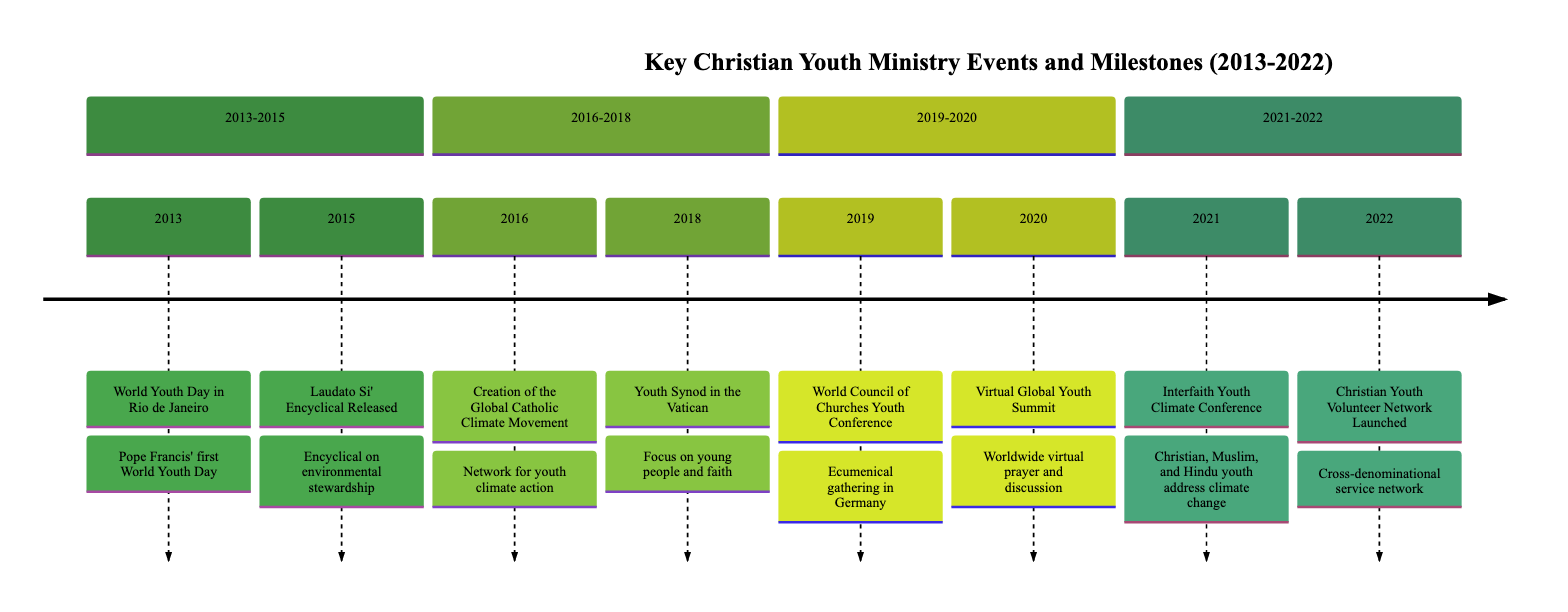What year did the World Youth Day in Rio de Janeiro occur? The timeline indicates that the World Youth Day took place in the year 2013.
Answer: 2013 How many events are listed in the timeline? Counting the events in the timeline, there are a total of 8 recorded events from 2013 to 2022.
Answer: 8 What was the main focus of the Youth Synod in the Vatican? The event description specifies that the synod focused on young people, faith, and vocational discernment.
Answer: Young people, faith, and vocational discernment Which conference in 2021 addressed climate change? The Interfaith Youth Climate Conference, held in 2021, specifically addressed climate change with youth leaders from different backgrounds.
Answer: Interfaith Youth Climate Conference In what year was the Christian Youth Volunteer Network launched? The timeline indicates that the Christian Youth Volunteer Network was launched in the year 2022.
Answer: 2022 What kind of gathering was the World Council of Churches Youth Conference in 2019? The description states that it was an ecumenical gathering aimed at fostering unity among Christian youth from various traditions.
Answer: Ecumenical gathering What significant document was released in 2015? The timeline mentions the release of the Laudato Si' Encyclical in 2015, which focused on environmental stewardship.
Answer: Laudato Si' Encyclical Which two events shared the year 2016? Upon reviewing the timeline, the events of the Global Catholic Climate Movement creation occurred in 2016. There is only one event listed for 2016, so it stands alone.
Answer: Creation of the Global Catholic Climate Movement What global event took place virtually in 2020? The timeline states that the Virtual Global Youth Summit took place in 2020 due to COVID-19.
Answer: Virtual Global Youth Summit 